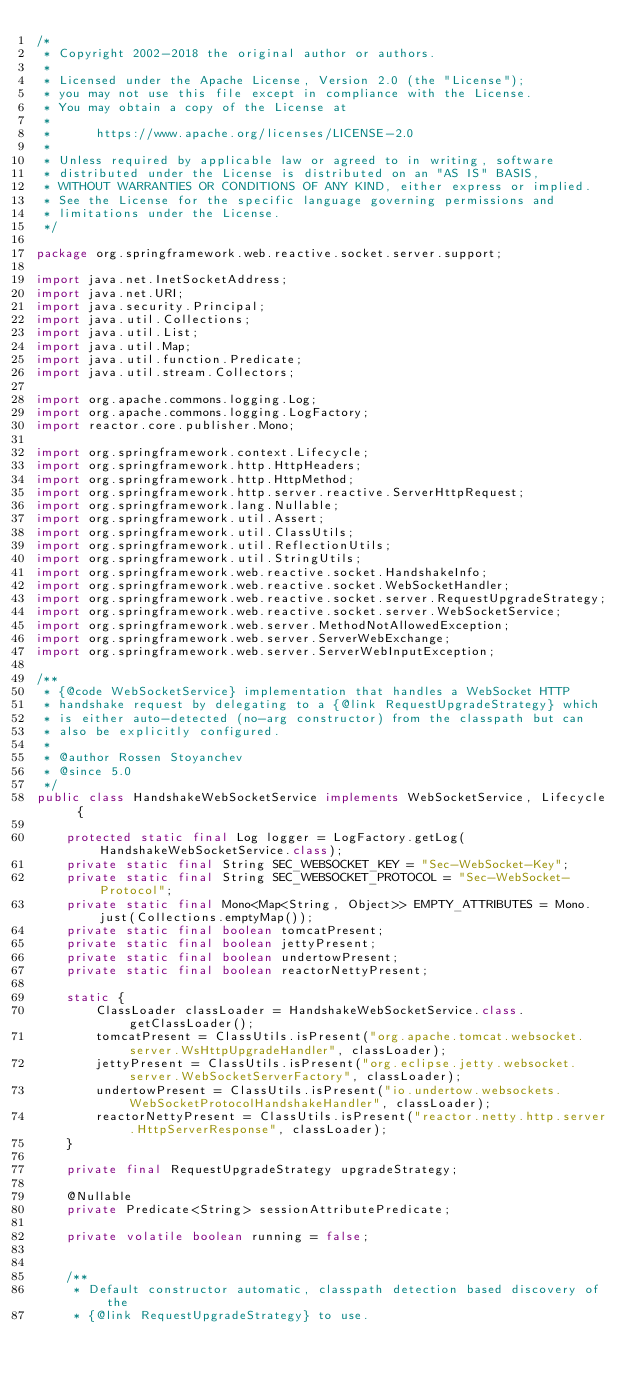Convert code to text. <code><loc_0><loc_0><loc_500><loc_500><_Java_>/*
 * Copyright 2002-2018 the original author or authors.
 *
 * Licensed under the Apache License, Version 2.0 (the "License");
 * you may not use this file except in compliance with the License.
 * You may obtain a copy of the License at
 *
 *      https://www.apache.org/licenses/LICENSE-2.0
 *
 * Unless required by applicable law or agreed to in writing, software
 * distributed under the License is distributed on an "AS IS" BASIS,
 * WITHOUT WARRANTIES OR CONDITIONS OF ANY KIND, either express or implied.
 * See the License for the specific language governing permissions and
 * limitations under the License.
 */

package org.springframework.web.reactive.socket.server.support;

import java.net.InetSocketAddress;
import java.net.URI;
import java.security.Principal;
import java.util.Collections;
import java.util.List;
import java.util.Map;
import java.util.function.Predicate;
import java.util.stream.Collectors;

import org.apache.commons.logging.Log;
import org.apache.commons.logging.LogFactory;
import reactor.core.publisher.Mono;

import org.springframework.context.Lifecycle;
import org.springframework.http.HttpHeaders;
import org.springframework.http.HttpMethod;
import org.springframework.http.server.reactive.ServerHttpRequest;
import org.springframework.lang.Nullable;
import org.springframework.util.Assert;
import org.springframework.util.ClassUtils;
import org.springframework.util.ReflectionUtils;
import org.springframework.util.StringUtils;
import org.springframework.web.reactive.socket.HandshakeInfo;
import org.springframework.web.reactive.socket.WebSocketHandler;
import org.springframework.web.reactive.socket.server.RequestUpgradeStrategy;
import org.springframework.web.reactive.socket.server.WebSocketService;
import org.springframework.web.server.MethodNotAllowedException;
import org.springframework.web.server.ServerWebExchange;
import org.springframework.web.server.ServerWebInputException;

/**
 * {@code WebSocketService} implementation that handles a WebSocket HTTP
 * handshake request by delegating to a {@link RequestUpgradeStrategy} which
 * is either auto-detected (no-arg constructor) from the classpath but can
 * also be explicitly configured.
 *
 * @author Rossen Stoyanchev
 * @since 5.0
 */
public class HandshakeWebSocketService implements WebSocketService, Lifecycle {

    protected static final Log logger = LogFactory.getLog(HandshakeWebSocketService.class);
    private static final String SEC_WEBSOCKET_KEY = "Sec-WebSocket-Key";
    private static final String SEC_WEBSOCKET_PROTOCOL = "Sec-WebSocket-Protocol";
    private static final Mono<Map<String, Object>> EMPTY_ATTRIBUTES = Mono.just(Collections.emptyMap());
    private static final boolean tomcatPresent;
    private static final boolean jettyPresent;
    private static final boolean undertowPresent;
    private static final boolean reactorNettyPresent;

    static {
        ClassLoader classLoader = HandshakeWebSocketService.class.getClassLoader();
        tomcatPresent = ClassUtils.isPresent("org.apache.tomcat.websocket.server.WsHttpUpgradeHandler", classLoader);
        jettyPresent = ClassUtils.isPresent("org.eclipse.jetty.websocket.server.WebSocketServerFactory", classLoader);
        undertowPresent = ClassUtils.isPresent("io.undertow.websockets.WebSocketProtocolHandshakeHandler", classLoader);
        reactorNettyPresent = ClassUtils.isPresent("reactor.netty.http.server.HttpServerResponse", classLoader);
    }

    private final RequestUpgradeStrategy upgradeStrategy;

    @Nullable
    private Predicate<String> sessionAttributePredicate;

    private volatile boolean running = false;


    /**
     * Default constructor automatic, classpath detection based discovery of the
     * {@link RequestUpgradeStrategy} to use.</code> 